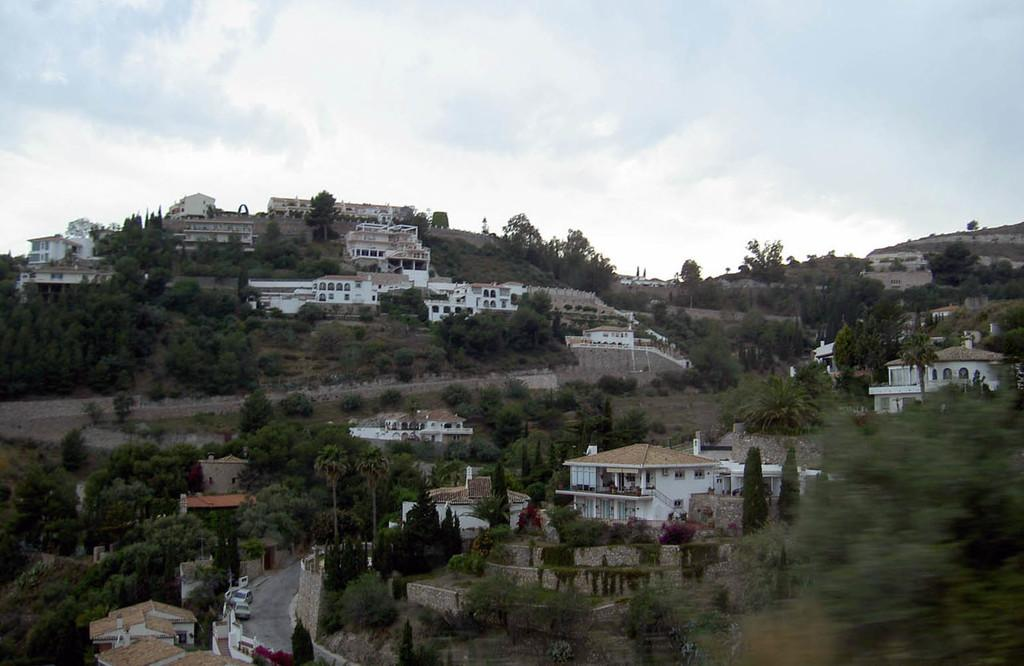What type of natural elements can be seen in the image? There are trees in the image. What type of man-made structures are present in the image? There are houses in the image. How would you describe the weather in the image? The sky is cloudy in the image. What type of transportation is visible on the road in the image? There are cars on the road in the image. What type of polish is being applied to the trees in the image? There is no polish being applied to the trees in the image; they are natural elements. What is the wish of the person driving the car in the image? We cannot determine the wish of the person driving the car in the image, as their thoughts are not visible. 